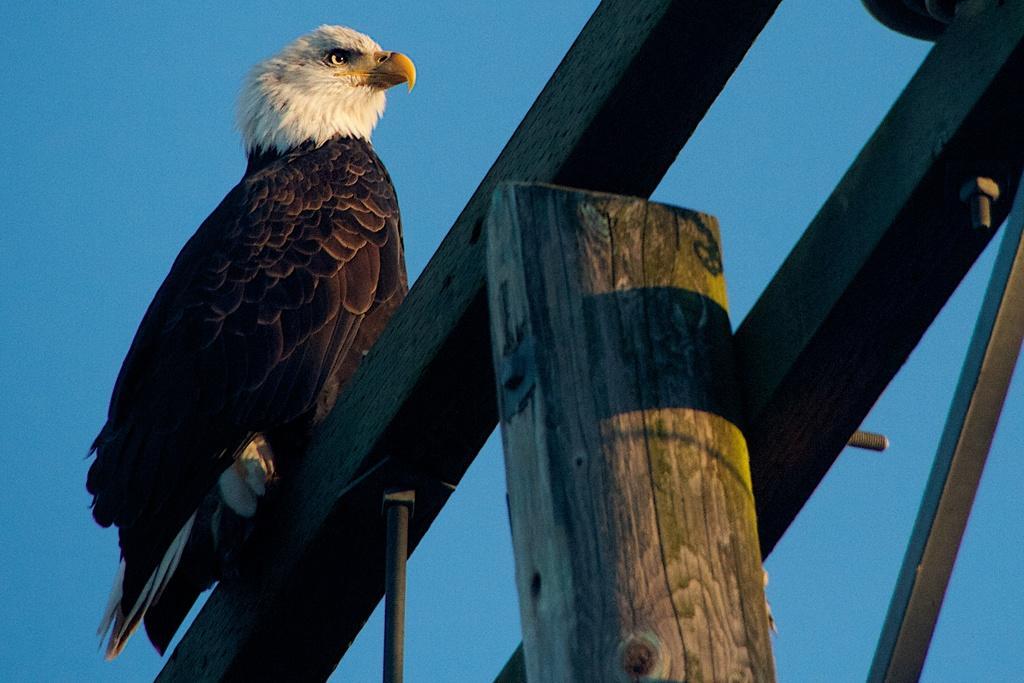Could you give a brief overview of what you see in this image? In this picture , I can see a sky and also i can see a wooden sticks and top on that wooden stick , I can see a animal standing. 